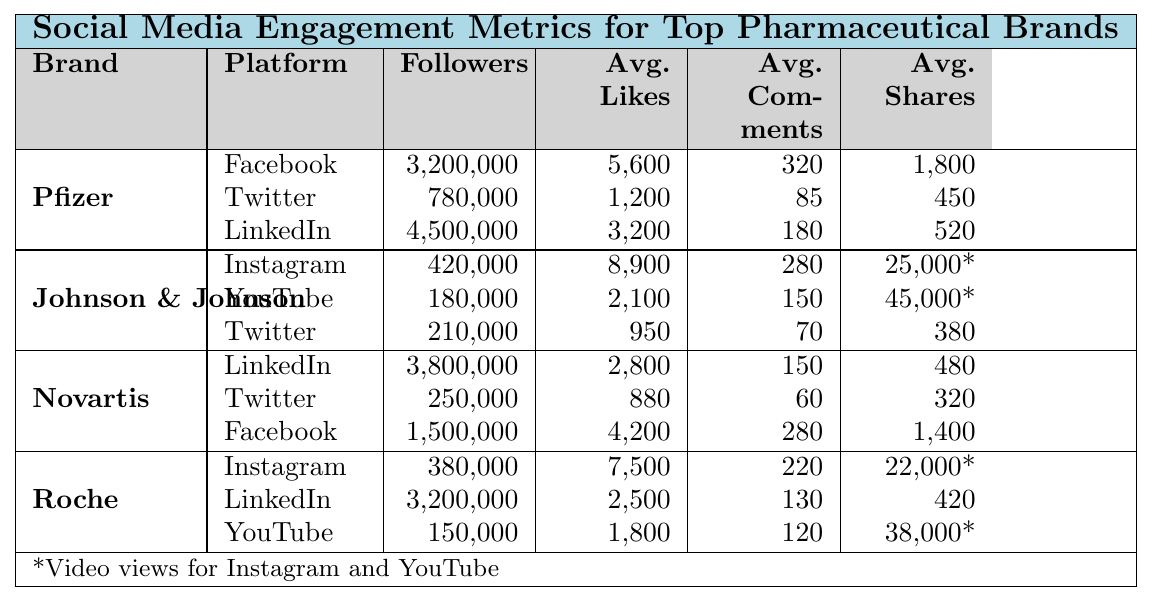What is the total number of followers for Pfizer across all platforms? Pfizer has 3,200,000 followers on Facebook, 780,000 on Twitter, and 4,500,000 on LinkedIn. To find the total, add these numbers: 3,200,000 + 780,000 + 4,500,000 = 8,480,000.
Answer: 8,480,000 Which platform has the highest average likes per post for Johnson & Johnson? Johnson & Johnson has an average of 8,900 likes per post on Instagram, 2,100 on YouTube, and 950 on Twitter. The highest average likes per post is on Instagram.
Answer: Instagram How many more followers does Roche have on LinkedIn compared to Novartis? Roche has 3,200,000 followers on LinkedIn and Novartis has 3,800,000 followers. To find the difference, subtract Roche's followers from Novartis's: 3,800,000 - 3,200,000 = 600,000.
Answer: 600,000 What are the average shares per post for Novartis on Facebook? For Novartis on Facebook, the average shares per post is 1,400 as indicated in the data.
Answer: 1,400 Is the average likes per post on Facebook for Pfizer higher than the average likes per post on Twitter? Pfizer has an average of 5,600 likes per post on Facebook and 1,200 likes on Twitter. Since 5,600 is greater than 1,200, the statement is true.
Answer: Yes Which brand has the highest average comments per post on Instagram? Johnson & Johnson has 280 average comments per post on Instagram, while Roche has 220. Since 280 is higher, Johnson & Johnson has more comments per post on Instagram.
Answer: Johnson & Johnson What is the combined total of average video views for Johnson & Johnson on YouTube and Roche on YouTube? Johnson & Johnson has an average of 45,000 views on YouTube and Roche has 38,000 views. To find the total, add these values: 45,000 + 38,000 = 83,000.
Answer: 83,000 How does the average reactions on LinkedIn for Novartis compare to that of Pfizer? Novartis has 2,800 average reactions on LinkedIn, while Pfizer has 3,200. Since 2,800 is less than 3,200, Novartis has fewer average reactions.
Answer: Fewer Which pharmaceutical brand has the lowest number of followers on Twitter? Johnson & Johnson has 210,000 followers on Twitter, while Novartis has 250,000 and Pfizer has 780,000. Johnson & Johnson has the lowest followers on Twitter.
Answer: Johnson & Johnson What is the average number of shares across all platforms for Roche? Roche has 22,000 shares on Instagram, 420 on LinkedIn, and 38,000 on YouTube. To find the average, add these shares: 22,000 + 420 + 38,000 = 60,420, then divide by 3 (the number of platforms): 60,420 / 3 = 20,140.
Answer: 20,140 